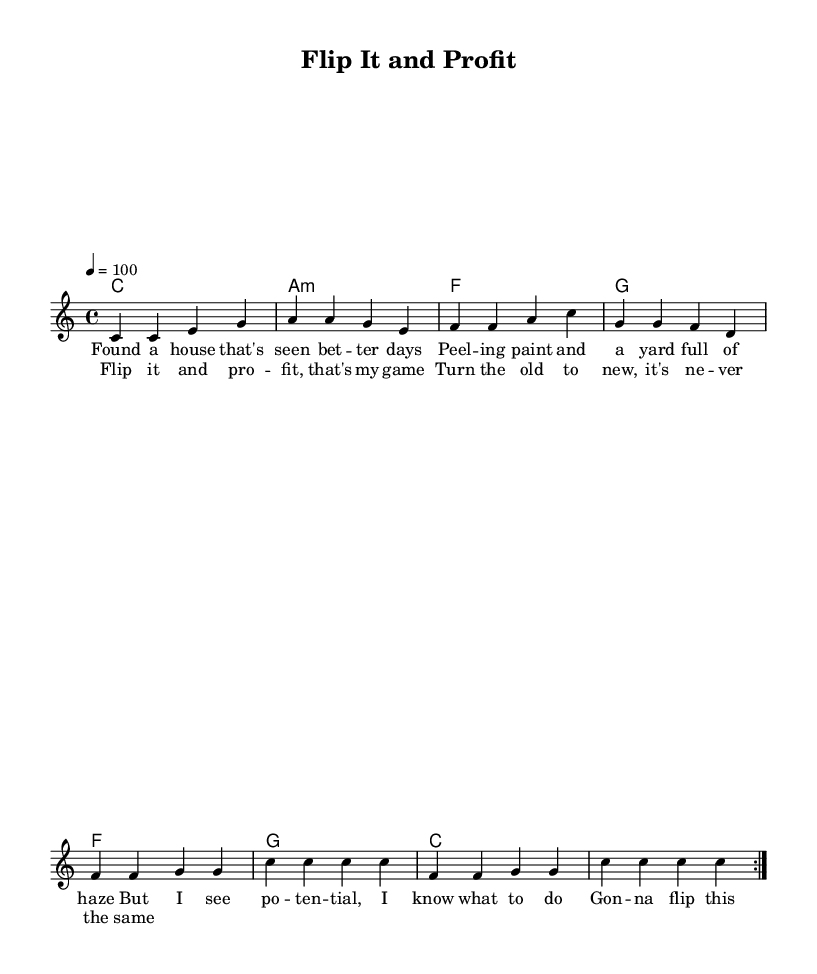What is the key signature of this music? The key signature is C major, which has no sharps or flats.
Answer: C major What is the time signature of this piece? The time signature is indicated by the “4/4” at the beginning, meaning there are four beats per measure.
Answer: 4/4 What is the tempo marking for this music? The tempo marking is specified as "4 = 100", indicating that there should be 100 beats per minute.
Answer: 100 How many times is the melody repeated in the first section? The repeat sign indicates that the melody section is repeated twice before moving on to the next part.
Answer: 2 What are the first two chords used in the piece? The first two chords listed under the chord names section are C and A minor, suggesting the harmonic foundation starts with these chords.
Answer: C and A minor What is the main theme of the lyrics in this music? The lyrics express a positive outlook on renovating and flipping houses, emphasizing potential and profit from distressed properties.
Answer: Renovation and profit How does the reggae style reflect in the rhythm of this piece? The piece has a laid-back feel typical of reggae, often characterized by its off-beat accents and prominent bass lines, enhancing the upbeat tempo.
Answer: Laid-back feel 